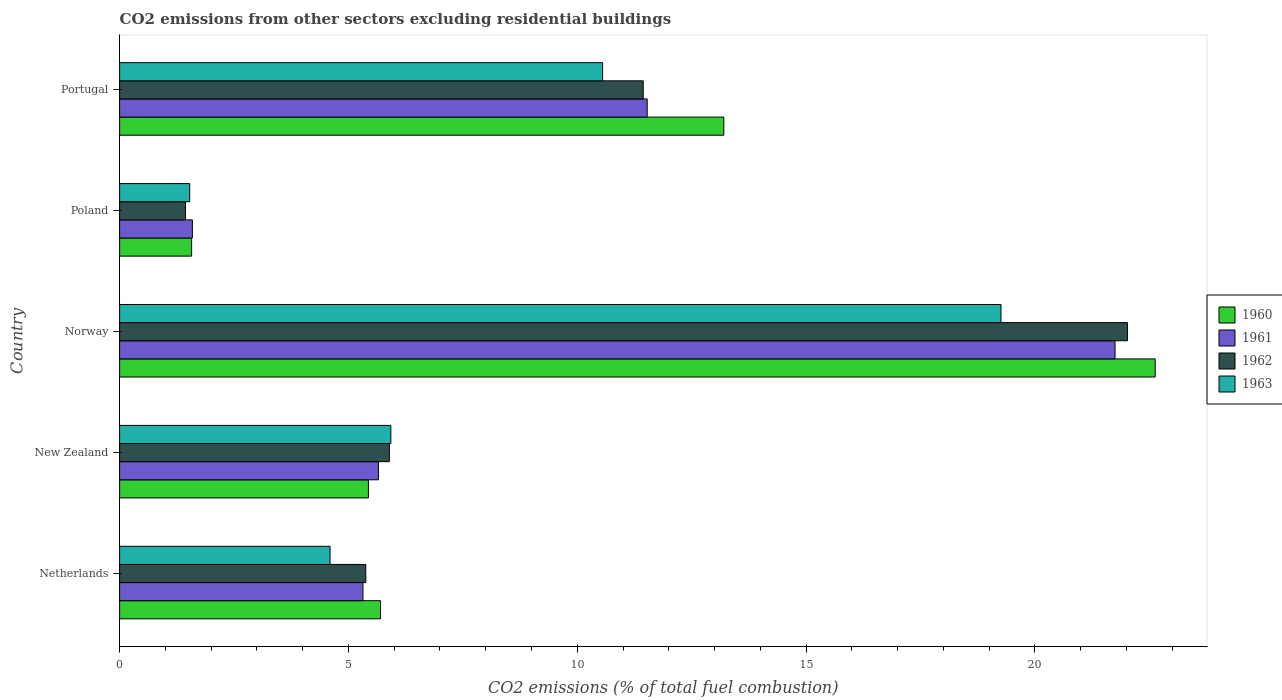How many different coloured bars are there?
Your answer should be compact. 4. How many groups of bars are there?
Provide a succinct answer. 5. How many bars are there on the 4th tick from the bottom?
Your answer should be compact. 4. What is the label of the 2nd group of bars from the top?
Your response must be concise. Poland. What is the total CO2 emitted in 1962 in New Zealand?
Offer a very short reply. 5.89. Across all countries, what is the maximum total CO2 emitted in 1963?
Your answer should be compact. 19.26. Across all countries, what is the minimum total CO2 emitted in 1961?
Your answer should be compact. 1.59. In which country was the total CO2 emitted in 1961 maximum?
Ensure brevity in your answer.  Norway. In which country was the total CO2 emitted in 1961 minimum?
Offer a terse response. Poland. What is the total total CO2 emitted in 1961 in the graph?
Give a very brief answer. 45.84. What is the difference between the total CO2 emitted in 1963 in Netherlands and that in Poland?
Make the answer very short. 3.07. What is the difference between the total CO2 emitted in 1961 in Portugal and the total CO2 emitted in 1963 in Netherlands?
Provide a short and direct response. 6.93. What is the average total CO2 emitted in 1963 per country?
Make the answer very short. 8.37. What is the difference between the total CO2 emitted in 1962 and total CO2 emitted in 1961 in New Zealand?
Make the answer very short. 0.24. What is the ratio of the total CO2 emitted in 1960 in Netherlands to that in Poland?
Offer a very short reply. 3.62. Is the difference between the total CO2 emitted in 1962 in Norway and Portugal greater than the difference between the total CO2 emitted in 1961 in Norway and Portugal?
Ensure brevity in your answer.  Yes. What is the difference between the highest and the second highest total CO2 emitted in 1963?
Provide a succinct answer. 8.7. What is the difference between the highest and the lowest total CO2 emitted in 1962?
Provide a succinct answer. 20.58. Is the sum of the total CO2 emitted in 1961 in New Zealand and Poland greater than the maximum total CO2 emitted in 1960 across all countries?
Provide a succinct answer. No. What does the 1st bar from the top in New Zealand represents?
Make the answer very short. 1963. What does the 3rd bar from the bottom in Portugal represents?
Give a very brief answer. 1962. Is it the case that in every country, the sum of the total CO2 emitted in 1960 and total CO2 emitted in 1962 is greater than the total CO2 emitted in 1963?
Your response must be concise. Yes. What is the difference between two consecutive major ticks on the X-axis?
Keep it short and to the point. 5. Does the graph contain grids?
Ensure brevity in your answer.  No. How are the legend labels stacked?
Offer a terse response. Vertical. What is the title of the graph?
Provide a succinct answer. CO2 emissions from other sectors excluding residential buildings. What is the label or title of the X-axis?
Give a very brief answer. CO2 emissions (% of total fuel combustion). What is the CO2 emissions (% of total fuel combustion) in 1960 in Netherlands?
Your answer should be compact. 5.7. What is the CO2 emissions (% of total fuel combustion) in 1961 in Netherlands?
Provide a succinct answer. 5.32. What is the CO2 emissions (% of total fuel combustion) of 1962 in Netherlands?
Your answer should be compact. 5.38. What is the CO2 emissions (% of total fuel combustion) in 1963 in Netherlands?
Your response must be concise. 4.6. What is the CO2 emissions (% of total fuel combustion) of 1960 in New Zealand?
Ensure brevity in your answer.  5.44. What is the CO2 emissions (% of total fuel combustion) of 1961 in New Zealand?
Offer a terse response. 5.66. What is the CO2 emissions (% of total fuel combustion) of 1962 in New Zealand?
Keep it short and to the point. 5.89. What is the CO2 emissions (% of total fuel combustion) in 1963 in New Zealand?
Give a very brief answer. 5.93. What is the CO2 emissions (% of total fuel combustion) of 1960 in Norway?
Keep it short and to the point. 22.63. What is the CO2 emissions (% of total fuel combustion) in 1961 in Norway?
Make the answer very short. 21.75. What is the CO2 emissions (% of total fuel combustion) of 1962 in Norway?
Give a very brief answer. 22.02. What is the CO2 emissions (% of total fuel combustion) in 1963 in Norway?
Ensure brevity in your answer.  19.26. What is the CO2 emissions (% of total fuel combustion) in 1960 in Poland?
Your response must be concise. 1.57. What is the CO2 emissions (% of total fuel combustion) of 1961 in Poland?
Offer a very short reply. 1.59. What is the CO2 emissions (% of total fuel combustion) in 1962 in Poland?
Offer a terse response. 1.44. What is the CO2 emissions (% of total fuel combustion) in 1963 in Poland?
Your answer should be compact. 1.53. What is the CO2 emissions (% of total fuel combustion) of 1960 in Portugal?
Make the answer very short. 13.2. What is the CO2 emissions (% of total fuel combustion) in 1961 in Portugal?
Your answer should be very brief. 11.53. What is the CO2 emissions (% of total fuel combustion) in 1962 in Portugal?
Your answer should be very brief. 11.44. What is the CO2 emissions (% of total fuel combustion) in 1963 in Portugal?
Offer a very short reply. 10.55. Across all countries, what is the maximum CO2 emissions (% of total fuel combustion) in 1960?
Offer a terse response. 22.63. Across all countries, what is the maximum CO2 emissions (% of total fuel combustion) in 1961?
Offer a terse response. 21.75. Across all countries, what is the maximum CO2 emissions (% of total fuel combustion) of 1962?
Ensure brevity in your answer.  22.02. Across all countries, what is the maximum CO2 emissions (% of total fuel combustion) of 1963?
Provide a succinct answer. 19.26. Across all countries, what is the minimum CO2 emissions (% of total fuel combustion) of 1960?
Keep it short and to the point. 1.57. Across all countries, what is the minimum CO2 emissions (% of total fuel combustion) in 1961?
Provide a succinct answer. 1.59. Across all countries, what is the minimum CO2 emissions (% of total fuel combustion) of 1962?
Your response must be concise. 1.44. Across all countries, what is the minimum CO2 emissions (% of total fuel combustion) of 1963?
Ensure brevity in your answer.  1.53. What is the total CO2 emissions (% of total fuel combustion) of 1960 in the graph?
Provide a succinct answer. 48.54. What is the total CO2 emissions (% of total fuel combustion) in 1961 in the graph?
Your answer should be compact. 45.84. What is the total CO2 emissions (% of total fuel combustion) in 1962 in the graph?
Offer a very short reply. 46.17. What is the total CO2 emissions (% of total fuel combustion) of 1963 in the graph?
Offer a terse response. 41.87. What is the difference between the CO2 emissions (% of total fuel combustion) of 1960 in Netherlands and that in New Zealand?
Offer a very short reply. 0.26. What is the difference between the CO2 emissions (% of total fuel combustion) of 1961 in Netherlands and that in New Zealand?
Make the answer very short. -0.34. What is the difference between the CO2 emissions (% of total fuel combustion) of 1962 in Netherlands and that in New Zealand?
Offer a terse response. -0.52. What is the difference between the CO2 emissions (% of total fuel combustion) in 1963 in Netherlands and that in New Zealand?
Provide a succinct answer. -1.33. What is the difference between the CO2 emissions (% of total fuel combustion) of 1960 in Netherlands and that in Norway?
Provide a succinct answer. -16.93. What is the difference between the CO2 emissions (% of total fuel combustion) in 1961 in Netherlands and that in Norway?
Keep it short and to the point. -16.43. What is the difference between the CO2 emissions (% of total fuel combustion) in 1962 in Netherlands and that in Norway?
Keep it short and to the point. -16.64. What is the difference between the CO2 emissions (% of total fuel combustion) of 1963 in Netherlands and that in Norway?
Your answer should be very brief. -14.66. What is the difference between the CO2 emissions (% of total fuel combustion) of 1960 in Netherlands and that in Poland?
Keep it short and to the point. 4.13. What is the difference between the CO2 emissions (% of total fuel combustion) of 1961 in Netherlands and that in Poland?
Provide a succinct answer. 3.73. What is the difference between the CO2 emissions (% of total fuel combustion) of 1962 in Netherlands and that in Poland?
Your answer should be compact. 3.94. What is the difference between the CO2 emissions (% of total fuel combustion) in 1963 in Netherlands and that in Poland?
Your response must be concise. 3.07. What is the difference between the CO2 emissions (% of total fuel combustion) of 1960 in Netherlands and that in Portugal?
Provide a succinct answer. -7.5. What is the difference between the CO2 emissions (% of total fuel combustion) in 1961 in Netherlands and that in Portugal?
Keep it short and to the point. -6.21. What is the difference between the CO2 emissions (% of total fuel combustion) in 1962 in Netherlands and that in Portugal?
Offer a very short reply. -6.06. What is the difference between the CO2 emissions (% of total fuel combustion) in 1963 in Netherlands and that in Portugal?
Keep it short and to the point. -5.96. What is the difference between the CO2 emissions (% of total fuel combustion) of 1960 in New Zealand and that in Norway?
Your answer should be compact. -17.19. What is the difference between the CO2 emissions (% of total fuel combustion) in 1961 in New Zealand and that in Norway?
Keep it short and to the point. -16.09. What is the difference between the CO2 emissions (% of total fuel combustion) of 1962 in New Zealand and that in Norway?
Your answer should be very brief. -16.13. What is the difference between the CO2 emissions (% of total fuel combustion) of 1963 in New Zealand and that in Norway?
Keep it short and to the point. -13.33. What is the difference between the CO2 emissions (% of total fuel combustion) in 1960 in New Zealand and that in Poland?
Provide a short and direct response. 3.86. What is the difference between the CO2 emissions (% of total fuel combustion) of 1961 in New Zealand and that in Poland?
Offer a terse response. 4.07. What is the difference between the CO2 emissions (% of total fuel combustion) of 1962 in New Zealand and that in Poland?
Make the answer very short. 4.45. What is the difference between the CO2 emissions (% of total fuel combustion) in 1963 in New Zealand and that in Poland?
Offer a very short reply. 4.39. What is the difference between the CO2 emissions (% of total fuel combustion) in 1960 in New Zealand and that in Portugal?
Provide a succinct answer. -7.76. What is the difference between the CO2 emissions (% of total fuel combustion) of 1961 in New Zealand and that in Portugal?
Your answer should be very brief. -5.87. What is the difference between the CO2 emissions (% of total fuel combustion) of 1962 in New Zealand and that in Portugal?
Make the answer very short. -5.55. What is the difference between the CO2 emissions (% of total fuel combustion) of 1963 in New Zealand and that in Portugal?
Your answer should be compact. -4.63. What is the difference between the CO2 emissions (% of total fuel combustion) in 1960 in Norway and that in Poland?
Keep it short and to the point. 21.05. What is the difference between the CO2 emissions (% of total fuel combustion) of 1961 in Norway and that in Poland?
Keep it short and to the point. 20.16. What is the difference between the CO2 emissions (% of total fuel combustion) in 1962 in Norway and that in Poland?
Provide a succinct answer. 20.58. What is the difference between the CO2 emissions (% of total fuel combustion) of 1963 in Norway and that in Poland?
Your answer should be compact. 17.73. What is the difference between the CO2 emissions (% of total fuel combustion) of 1960 in Norway and that in Portugal?
Ensure brevity in your answer.  9.43. What is the difference between the CO2 emissions (% of total fuel combustion) in 1961 in Norway and that in Portugal?
Your answer should be compact. 10.22. What is the difference between the CO2 emissions (% of total fuel combustion) in 1962 in Norway and that in Portugal?
Your answer should be compact. 10.58. What is the difference between the CO2 emissions (% of total fuel combustion) of 1963 in Norway and that in Portugal?
Your answer should be compact. 8.7. What is the difference between the CO2 emissions (% of total fuel combustion) in 1960 in Poland and that in Portugal?
Give a very brief answer. -11.63. What is the difference between the CO2 emissions (% of total fuel combustion) in 1961 in Poland and that in Portugal?
Your answer should be compact. -9.94. What is the difference between the CO2 emissions (% of total fuel combustion) of 1962 in Poland and that in Portugal?
Make the answer very short. -10. What is the difference between the CO2 emissions (% of total fuel combustion) in 1963 in Poland and that in Portugal?
Offer a very short reply. -9.02. What is the difference between the CO2 emissions (% of total fuel combustion) in 1960 in Netherlands and the CO2 emissions (% of total fuel combustion) in 1961 in New Zealand?
Offer a terse response. 0.05. What is the difference between the CO2 emissions (% of total fuel combustion) in 1960 in Netherlands and the CO2 emissions (% of total fuel combustion) in 1962 in New Zealand?
Your response must be concise. -0.19. What is the difference between the CO2 emissions (% of total fuel combustion) of 1960 in Netherlands and the CO2 emissions (% of total fuel combustion) of 1963 in New Zealand?
Provide a succinct answer. -0.23. What is the difference between the CO2 emissions (% of total fuel combustion) in 1961 in Netherlands and the CO2 emissions (% of total fuel combustion) in 1962 in New Zealand?
Your answer should be very brief. -0.58. What is the difference between the CO2 emissions (% of total fuel combustion) in 1961 in Netherlands and the CO2 emissions (% of total fuel combustion) in 1963 in New Zealand?
Give a very brief answer. -0.61. What is the difference between the CO2 emissions (% of total fuel combustion) in 1962 in Netherlands and the CO2 emissions (% of total fuel combustion) in 1963 in New Zealand?
Ensure brevity in your answer.  -0.55. What is the difference between the CO2 emissions (% of total fuel combustion) of 1960 in Netherlands and the CO2 emissions (% of total fuel combustion) of 1961 in Norway?
Provide a short and direct response. -16.05. What is the difference between the CO2 emissions (% of total fuel combustion) in 1960 in Netherlands and the CO2 emissions (% of total fuel combustion) in 1962 in Norway?
Make the answer very short. -16.32. What is the difference between the CO2 emissions (% of total fuel combustion) of 1960 in Netherlands and the CO2 emissions (% of total fuel combustion) of 1963 in Norway?
Your response must be concise. -13.56. What is the difference between the CO2 emissions (% of total fuel combustion) in 1961 in Netherlands and the CO2 emissions (% of total fuel combustion) in 1962 in Norway?
Keep it short and to the point. -16.7. What is the difference between the CO2 emissions (% of total fuel combustion) of 1961 in Netherlands and the CO2 emissions (% of total fuel combustion) of 1963 in Norway?
Keep it short and to the point. -13.94. What is the difference between the CO2 emissions (% of total fuel combustion) in 1962 in Netherlands and the CO2 emissions (% of total fuel combustion) in 1963 in Norway?
Give a very brief answer. -13.88. What is the difference between the CO2 emissions (% of total fuel combustion) of 1960 in Netherlands and the CO2 emissions (% of total fuel combustion) of 1961 in Poland?
Offer a very short reply. 4.11. What is the difference between the CO2 emissions (% of total fuel combustion) in 1960 in Netherlands and the CO2 emissions (% of total fuel combustion) in 1962 in Poland?
Offer a terse response. 4.26. What is the difference between the CO2 emissions (% of total fuel combustion) of 1960 in Netherlands and the CO2 emissions (% of total fuel combustion) of 1963 in Poland?
Give a very brief answer. 4.17. What is the difference between the CO2 emissions (% of total fuel combustion) in 1961 in Netherlands and the CO2 emissions (% of total fuel combustion) in 1962 in Poland?
Offer a very short reply. 3.88. What is the difference between the CO2 emissions (% of total fuel combustion) in 1961 in Netherlands and the CO2 emissions (% of total fuel combustion) in 1963 in Poland?
Provide a succinct answer. 3.79. What is the difference between the CO2 emissions (% of total fuel combustion) of 1962 in Netherlands and the CO2 emissions (% of total fuel combustion) of 1963 in Poland?
Ensure brevity in your answer.  3.85. What is the difference between the CO2 emissions (% of total fuel combustion) in 1960 in Netherlands and the CO2 emissions (% of total fuel combustion) in 1961 in Portugal?
Your answer should be very brief. -5.83. What is the difference between the CO2 emissions (% of total fuel combustion) in 1960 in Netherlands and the CO2 emissions (% of total fuel combustion) in 1962 in Portugal?
Your answer should be compact. -5.74. What is the difference between the CO2 emissions (% of total fuel combustion) of 1960 in Netherlands and the CO2 emissions (% of total fuel combustion) of 1963 in Portugal?
Offer a terse response. -4.85. What is the difference between the CO2 emissions (% of total fuel combustion) of 1961 in Netherlands and the CO2 emissions (% of total fuel combustion) of 1962 in Portugal?
Provide a succinct answer. -6.12. What is the difference between the CO2 emissions (% of total fuel combustion) in 1961 in Netherlands and the CO2 emissions (% of total fuel combustion) in 1963 in Portugal?
Your answer should be compact. -5.24. What is the difference between the CO2 emissions (% of total fuel combustion) of 1962 in Netherlands and the CO2 emissions (% of total fuel combustion) of 1963 in Portugal?
Offer a very short reply. -5.17. What is the difference between the CO2 emissions (% of total fuel combustion) of 1960 in New Zealand and the CO2 emissions (% of total fuel combustion) of 1961 in Norway?
Your response must be concise. -16.31. What is the difference between the CO2 emissions (% of total fuel combustion) of 1960 in New Zealand and the CO2 emissions (% of total fuel combustion) of 1962 in Norway?
Give a very brief answer. -16.58. What is the difference between the CO2 emissions (% of total fuel combustion) of 1960 in New Zealand and the CO2 emissions (% of total fuel combustion) of 1963 in Norway?
Give a very brief answer. -13.82. What is the difference between the CO2 emissions (% of total fuel combustion) of 1961 in New Zealand and the CO2 emissions (% of total fuel combustion) of 1962 in Norway?
Make the answer very short. -16.36. What is the difference between the CO2 emissions (% of total fuel combustion) in 1961 in New Zealand and the CO2 emissions (% of total fuel combustion) in 1963 in Norway?
Keep it short and to the point. -13.6. What is the difference between the CO2 emissions (% of total fuel combustion) of 1962 in New Zealand and the CO2 emissions (% of total fuel combustion) of 1963 in Norway?
Offer a terse response. -13.36. What is the difference between the CO2 emissions (% of total fuel combustion) of 1960 in New Zealand and the CO2 emissions (% of total fuel combustion) of 1961 in Poland?
Offer a very short reply. 3.85. What is the difference between the CO2 emissions (% of total fuel combustion) of 1960 in New Zealand and the CO2 emissions (% of total fuel combustion) of 1962 in Poland?
Ensure brevity in your answer.  4. What is the difference between the CO2 emissions (% of total fuel combustion) of 1960 in New Zealand and the CO2 emissions (% of total fuel combustion) of 1963 in Poland?
Give a very brief answer. 3.91. What is the difference between the CO2 emissions (% of total fuel combustion) of 1961 in New Zealand and the CO2 emissions (% of total fuel combustion) of 1962 in Poland?
Give a very brief answer. 4.22. What is the difference between the CO2 emissions (% of total fuel combustion) in 1961 in New Zealand and the CO2 emissions (% of total fuel combustion) in 1963 in Poland?
Ensure brevity in your answer.  4.12. What is the difference between the CO2 emissions (% of total fuel combustion) of 1962 in New Zealand and the CO2 emissions (% of total fuel combustion) of 1963 in Poland?
Your answer should be very brief. 4.36. What is the difference between the CO2 emissions (% of total fuel combustion) of 1960 in New Zealand and the CO2 emissions (% of total fuel combustion) of 1961 in Portugal?
Provide a succinct answer. -6.09. What is the difference between the CO2 emissions (% of total fuel combustion) of 1960 in New Zealand and the CO2 emissions (% of total fuel combustion) of 1962 in Portugal?
Give a very brief answer. -6. What is the difference between the CO2 emissions (% of total fuel combustion) of 1960 in New Zealand and the CO2 emissions (% of total fuel combustion) of 1963 in Portugal?
Ensure brevity in your answer.  -5.12. What is the difference between the CO2 emissions (% of total fuel combustion) of 1961 in New Zealand and the CO2 emissions (% of total fuel combustion) of 1962 in Portugal?
Ensure brevity in your answer.  -5.79. What is the difference between the CO2 emissions (% of total fuel combustion) in 1961 in New Zealand and the CO2 emissions (% of total fuel combustion) in 1963 in Portugal?
Keep it short and to the point. -4.9. What is the difference between the CO2 emissions (% of total fuel combustion) of 1962 in New Zealand and the CO2 emissions (% of total fuel combustion) of 1963 in Portugal?
Ensure brevity in your answer.  -4.66. What is the difference between the CO2 emissions (% of total fuel combustion) in 1960 in Norway and the CO2 emissions (% of total fuel combustion) in 1961 in Poland?
Give a very brief answer. 21.04. What is the difference between the CO2 emissions (% of total fuel combustion) of 1960 in Norway and the CO2 emissions (% of total fuel combustion) of 1962 in Poland?
Provide a short and direct response. 21.19. What is the difference between the CO2 emissions (% of total fuel combustion) of 1960 in Norway and the CO2 emissions (% of total fuel combustion) of 1963 in Poland?
Your response must be concise. 21.1. What is the difference between the CO2 emissions (% of total fuel combustion) of 1961 in Norway and the CO2 emissions (% of total fuel combustion) of 1962 in Poland?
Your response must be concise. 20.31. What is the difference between the CO2 emissions (% of total fuel combustion) of 1961 in Norway and the CO2 emissions (% of total fuel combustion) of 1963 in Poland?
Make the answer very short. 20.22. What is the difference between the CO2 emissions (% of total fuel combustion) in 1962 in Norway and the CO2 emissions (% of total fuel combustion) in 1963 in Poland?
Ensure brevity in your answer.  20.49. What is the difference between the CO2 emissions (% of total fuel combustion) of 1960 in Norway and the CO2 emissions (% of total fuel combustion) of 1961 in Portugal?
Ensure brevity in your answer.  11.1. What is the difference between the CO2 emissions (% of total fuel combustion) in 1960 in Norway and the CO2 emissions (% of total fuel combustion) in 1962 in Portugal?
Provide a succinct answer. 11.19. What is the difference between the CO2 emissions (% of total fuel combustion) in 1960 in Norway and the CO2 emissions (% of total fuel combustion) in 1963 in Portugal?
Give a very brief answer. 12.07. What is the difference between the CO2 emissions (% of total fuel combustion) of 1961 in Norway and the CO2 emissions (% of total fuel combustion) of 1962 in Portugal?
Make the answer very short. 10.31. What is the difference between the CO2 emissions (% of total fuel combustion) in 1961 in Norway and the CO2 emissions (% of total fuel combustion) in 1963 in Portugal?
Offer a very short reply. 11.2. What is the difference between the CO2 emissions (% of total fuel combustion) in 1962 in Norway and the CO2 emissions (% of total fuel combustion) in 1963 in Portugal?
Your answer should be very brief. 11.47. What is the difference between the CO2 emissions (% of total fuel combustion) in 1960 in Poland and the CO2 emissions (% of total fuel combustion) in 1961 in Portugal?
Make the answer very short. -9.95. What is the difference between the CO2 emissions (% of total fuel combustion) in 1960 in Poland and the CO2 emissions (% of total fuel combustion) in 1962 in Portugal?
Offer a terse response. -9.87. What is the difference between the CO2 emissions (% of total fuel combustion) of 1960 in Poland and the CO2 emissions (% of total fuel combustion) of 1963 in Portugal?
Make the answer very short. -8.98. What is the difference between the CO2 emissions (% of total fuel combustion) of 1961 in Poland and the CO2 emissions (% of total fuel combustion) of 1962 in Portugal?
Your answer should be very brief. -9.85. What is the difference between the CO2 emissions (% of total fuel combustion) of 1961 in Poland and the CO2 emissions (% of total fuel combustion) of 1963 in Portugal?
Your answer should be very brief. -8.96. What is the difference between the CO2 emissions (% of total fuel combustion) of 1962 in Poland and the CO2 emissions (% of total fuel combustion) of 1963 in Portugal?
Give a very brief answer. -9.11. What is the average CO2 emissions (% of total fuel combustion) in 1960 per country?
Give a very brief answer. 9.71. What is the average CO2 emissions (% of total fuel combustion) in 1961 per country?
Keep it short and to the point. 9.17. What is the average CO2 emissions (% of total fuel combustion) in 1962 per country?
Give a very brief answer. 9.23. What is the average CO2 emissions (% of total fuel combustion) in 1963 per country?
Ensure brevity in your answer.  8.37. What is the difference between the CO2 emissions (% of total fuel combustion) in 1960 and CO2 emissions (% of total fuel combustion) in 1961 in Netherlands?
Offer a very short reply. 0.38. What is the difference between the CO2 emissions (% of total fuel combustion) of 1960 and CO2 emissions (% of total fuel combustion) of 1962 in Netherlands?
Make the answer very short. 0.32. What is the difference between the CO2 emissions (% of total fuel combustion) of 1960 and CO2 emissions (% of total fuel combustion) of 1963 in Netherlands?
Your answer should be compact. 1.1. What is the difference between the CO2 emissions (% of total fuel combustion) of 1961 and CO2 emissions (% of total fuel combustion) of 1962 in Netherlands?
Offer a very short reply. -0.06. What is the difference between the CO2 emissions (% of total fuel combustion) in 1961 and CO2 emissions (% of total fuel combustion) in 1963 in Netherlands?
Give a very brief answer. 0.72. What is the difference between the CO2 emissions (% of total fuel combustion) in 1962 and CO2 emissions (% of total fuel combustion) in 1963 in Netherlands?
Keep it short and to the point. 0.78. What is the difference between the CO2 emissions (% of total fuel combustion) of 1960 and CO2 emissions (% of total fuel combustion) of 1961 in New Zealand?
Offer a very short reply. -0.22. What is the difference between the CO2 emissions (% of total fuel combustion) in 1960 and CO2 emissions (% of total fuel combustion) in 1962 in New Zealand?
Your response must be concise. -0.46. What is the difference between the CO2 emissions (% of total fuel combustion) in 1960 and CO2 emissions (% of total fuel combustion) in 1963 in New Zealand?
Give a very brief answer. -0.49. What is the difference between the CO2 emissions (% of total fuel combustion) of 1961 and CO2 emissions (% of total fuel combustion) of 1962 in New Zealand?
Give a very brief answer. -0.24. What is the difference between the CO2 emissions (% of total fuel combustion) in 1961 and CO2 emissions (% of total fuel combustion) in 1963 in New Zealand?
Provide a succinct answer. -0.27. What is the difference between the CO2 emissions (% of total fuel combustion) in 1962 and CO2 emissions (% of total fuel combustion) in 1963 in New Zealand?
Make the answer very short. -0.03. What is the difference between the CO2 emissions (% of total fuel combustion) in 1960 and CO2 emissions (% of total fuel combustion) in 1961 in Norway?
Make the answer very short. 0.88. What is the difference between the CO2 emissions (% of total fuel combustion) of 1960 and CO2 emissions (% of total fuel combustion) of 1962 in Norway?
Provide a short and direct response. 0.61. What is the difference between the CO2 emissions (% of total fuel combustion) in 1960 and CO2 emissions (% of total fuel combustion) in 1963 in Norway?
Your answer should be compact. 3.37. What is the difference between the CO2 emissions (% of total fuel combustion) in 1961 and CO2 emissions (% of total fuel combustion) in 1962 in Norway?
Your answer should be very brief. -0.27. What is the difference between the CO2 emissions (% of total fuel combustion) in 1961 and CO2 emissions (% of total fuel combustion) in 1963 in Norway?
Provide a succinct answer. 2.49. What is the difference between the CO2 emissions (% of total fuel combustion) of 1962 and CO2 emissions (% of total fuel combustion) of 1963 in Norway?
Ensure brevity in your answer.  2.76. What is the difference between the CO2 emissions (% of total fuel combustion) in 1960 and CO2 emissions (% of total fuel combustion) in 1961 in Poland?
Offer a very short reply. -0.02. What is the difference between the CO2 emissions (% of total fuel combustion) of 1960 and CO2 emissions (% of total fuel combustion) of 1962 in Poland?
Offer a terse response. 0.13. What is the difference between the CO2 emissions (% of total fuel combustion) of 1960 and CO2 emissions (% of total fuel combustion) of 1963 in Poland?
Your answer should be compact. 0.04. What is the difference between the CO2 emissions (% of total fuel combustion) of 1961 and CO2 emissions (% of total fuel combustion) of 1962 in Poland?
Make the answer very short. 0.15. What is the difference between the CO2 emissions (% of total fuel combustion) of 1961 and CO2 emissions (% of total fuel combustion) of 1963 in Poland?
Keep it short and to the point. 0.06. What is the difference between the CO2 emissions (% of total fuel combustion) of 1962 and CO2 emissions (% of total fuel combustion) of 1963 in Poland?
Provide a short and direct response. -0.09. What is the difference between the CO2 emissions (% of total fuel combustion) in 1960 and CO2 emissions (% of total fuel combustion) in 1961 in Portugal?
Give a very brief answer. 1.67. What is the difference between the CO2 emissions (% of total fuel combustion) in 1960 and CO2 emissions (% of total fuel combustion) in 1962 in Portugal?
Your response must be concise. 1.76. What is the difference between the CO2 emissions (% of total fuel combustion) of 1960 and CO2 emissions (% of total fuel combustion) of 1963 in Portugal?
Offer a terse response. 2.65. What is the difference between the CO2 emissions (% of total fuel combustion) in 1961 and CO2 emissions (% of total fuel combustion) in 1962 in Portugal?
Give a very brief answer. 0.09. What is the difference between the CO2 emissions (% of total fuel combustion) in 1961 and CO2 emissions (% of total fuel combustion) in 1963 in Portugal?
Keep it short and to the point. 0.97. What is the difference between the CO2 emissions (% of total fuel combustion) in 1962 and CO2 emissions (% of total fuel combustion) in 1963 in Portugal?
Keep it short and to the point. 0.89. What is the ratio of the CO2 emissions (% of total fuel combustion) of 1960 in Netherlands to that in New Zealand?
Ensure brevity in your answer.  1.05. What is the ratio of the CO2 emissions (% of total fuel combustion) in 1961 in Netherlands to that in New Zealand?
Keep it short and to the point. 0.94. What is the ratio of the CO2 emissions (% of total fuel combustion) of 1962 in Netherlands to that in New Zealand?
Your answer should be compact. 0.91. What is the ratio of the CO2 emissions (% of total fuel combustion) of 1963 in Netherlands to that in New Zealand?
Your answer should be compact. 0.78. What is the ratio of the CO2 emissions (% of total fuel combustion) of 1960 in Netherlands to that in Norway?
Ensure brevity in your answer.  0.25. What is the ratio of the CO2 emissions (% of total fuel combustion) of 1961 in Netherlands to that in Norway?
Make the answer very short. 0.24. What is the ratio of the CO2 emissions (% of total fuel combustion) in 1962 in Netherlands to that in Norway?
Keep it short and to the point. 0.24. What is the ratio of the CO2 emissions (% of total fuel combustion) in 1963 in Netherlands to that in Norway?
Give a very brief answer. 0.24. What is the ratio of the CO2 emissions (% of total fuel combustion) of 1960 in Netherlands to that in Poland?
Offer a very short reply. 3.62. What is the ratio of the CO2 emissions (% of total fuel combustion) in 1961 in Netherlands to that in Poland?
Offer a terse response. 3.34. What is the ratio of the CO2 emissions (% of total fuel combustion) of 1962 in Netherlands to that in Poland?
Give a very brief answer. 3.74. What is the ratio of the CO2 emissions (% of total fuel combustion) in 1963 in Netherlands to that in Poland?
Your response must be concise. 3. What is the ratio of the CO2 emissions (% of total fuel combustion) of 1960 in Netherlands to that in Portugal?
Your response must be concise. 0.43. What is the ratio of the CO2 emissions (% of total fuel combustion) in 1961 in Netherlands to that in Portugal?
Your answer should be very brief. 0.46. What is the ratio of the CO2 emissions (% of total fuel combustion) of 1962 in Netherlands to that in Portugal?
Offer a very short reply. 0.47. What is the ratio of the CO2 emissions (% of total fuel combustion) of 1963 in Netherlands to that in Portugal?
Provide a succinct answer. 0.44. What is the ratio of the CO2 emissions (% of total fuel combustion) in 1960 in New Zealand to that in Norway?
Give a very brief answer. 0.24. What is the ratio of the CO2 emissions (% of total fuel combustion) in 1961 in New Zealand to that in Norway?
Offer a very short reply. 0.26. What is the ratio of the CO2 emissions (% of total fuel combustion) of 1962 in New Zealand to that in Norway?
Offer a terse response. 0.27. What is the ratio of the CO2 emissions (% of total fuel combustion) of 1963 in New Zealand to that in Norway?
Offer a terse response. 0.31. What is the ratio of the CO2 emissions (% of total fuel combustion) in 1960 in New Zealand to that in Poland?
Provide a short and direct response. 3.46. What is the ratio of the CO2 emissions (% of total fuel combustion) of 1961 in New Zealand to that in Poland?
Provide a short and direct response. 3.56. What is the ratio of the CO2 emissions (% of total fuel combustion) of 1962 in New Zealand to that in Poland?
Offer a very short reply. 4.1. What is the ratio of the CO2 emissions (% of total fuel combustion) in 1963 in New Zealand to that in Poland?
Your answer should be very brief. 3.87. What is the ratio of the CO2 emissions (% of total fuel combustion) of 1960 in New Zealand to that in Portugal?
Your answer should be very brief. 0.41. What is the ratio of the CO2 emissions (% of total fuel combustion) of 1961 in New Zealand to that in Portugal?
Provide a short and direct response. 0.49. What is the ratio of the CO2 emissions (% of total fuel combustion) of 1962 in New Zealand to that in Portugal?
Give a very brief answer. 0.52. What is the ratio of the CO2 emissions (% of total fuel combustion) of 1963 in New Zealand to that in Portugal?
Offer a terse response. 0.56. What is the ratio of the CO2 emissions (% of total fuel combustion) in 1960 in Norway to that in Poland?
Give a very brief answer. 14.38. What is the ratio of the CO2 emissions (% of total fuel combustion) in 1961 in Norway to that in Poland?
Offer a terse response. 13.68. What is the ratio of the CO2 emissions (% of total fuel combustion) in 1962 in Norway to that in Poland?
Provide a succinct answer. 15.3. What is the ratio of the CO2 emissions (% of total fuel combustion) in 1963 in Norway to that in Poland?
Offer a very short reply. 12.57. What is the ratio of the CO2 emissions (% of total fuel combustion) in 1960 in Norway to that in Portugal?
Offer a terse response. 1.71. What is the ratio of the CO2 emissions (% of total fuel combustion) in 1961 in Norway to that in Portugal?
Provide a succinct answer. 1.89. What is the ratio of the CO2 emissions (% of total fuel combustion) of 1962 in Norway to that in Portugal?
Give a very brief answer. 1.92. What is the ratio of the CO2 emissions (% of total fuel combustion) of 1963 in Norway to that in Portugal?
Provide a short and direct response. 1.82. What is the ratio of the CO2 emissions (% of total fuel combustion) of 1960 in Poland to that in Portugal?
Make the answer very short. 0.12. What is the ratio of the CO2 emissions (% of total fuel combustion) in 1961 in Poland to that in Portugal?
Your answer should be compact. 0.14. What is the ratio of the CO2 emissions (% of total fuel combustion) in 1962 in Poland to that in Portugal?
Offer a very short reply. 0.13. What is the ratio of the CO2 emissions (% of total fuel combustion) in 1963 in Poland to that in Portugal?
Provide a short and direct response. 0.15. What is the difference between the highest and the second highest CO2 emissions (% of total fuel combustion) in 1960?
Your answer should be very brief. 9.43. What is the difference between the highest and the second highest CO2 emissions (% of total fuel combustion) of 1961?
Provide a succinct answer. 10.22. What is the difference between the highest and the second highest CO2 emissions (% of total fuel combustion) in 1962?
Your answer should be compact. 10.58. What is the difference between the highest and the second highest CO2 emissions (% of total fuel combustion) in 1963?
Your answer should be very brief. 8.7. What is the difference between the highest and the lowest CO2 emissions (% of total fuel combustion) of 1960?
Give a very brief answer. 21.05. What is the difference between the highest and the lowest CO2 emissions (% of total fuel combustion) of 1961?
Give a very brief answer. 20.16. What is the difference between the highest and the lowest CO2 emissions (% of total fuel combustion) of 1962?
Provide a short and direct response. 20.58. What is the difference between the highest and the lowest CO2 emissions (% of total fuel combustion) in 1963?
Offer a very short reply. 17.73. 